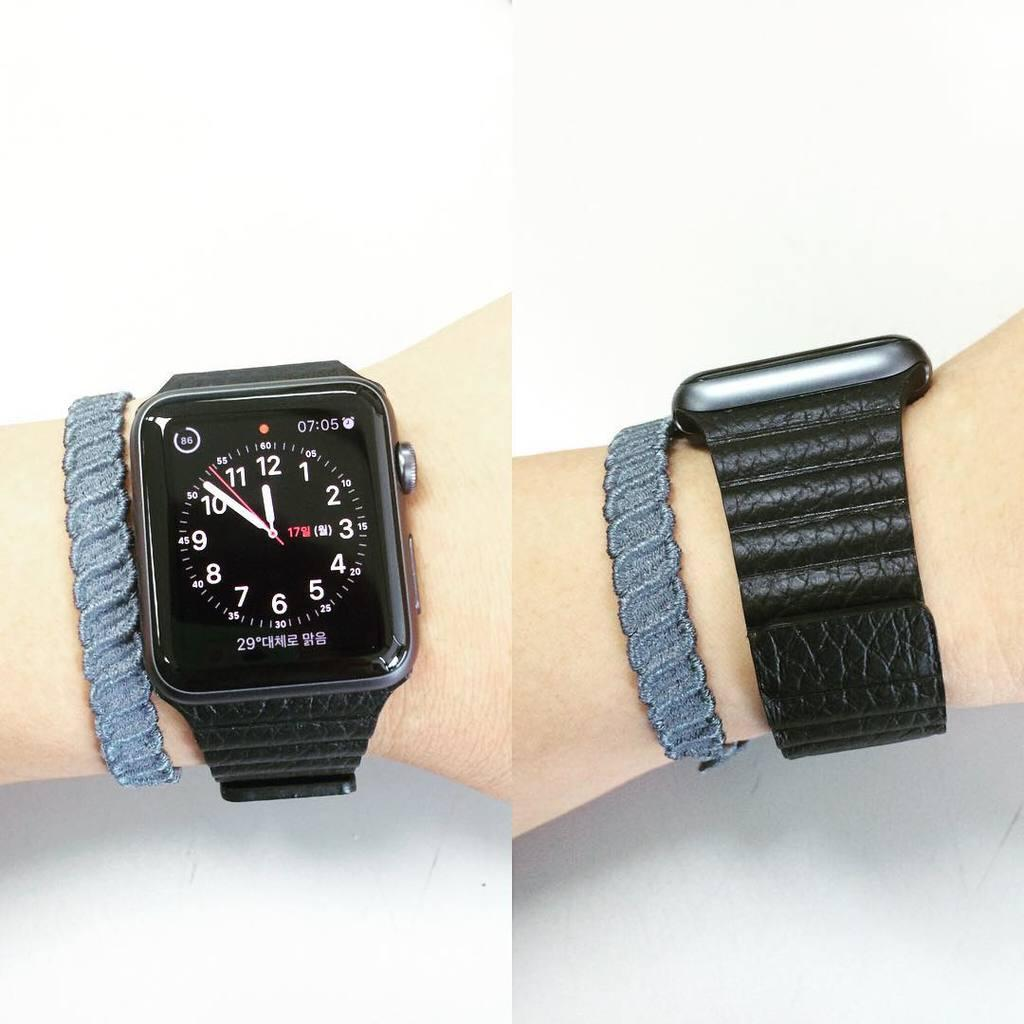What type of artwork is featured in the image? The image contains a collage. What is the main subject of the collage? The collage depicts a person's hand. What can be seen on the person's hand in the collage? The person's hand is wearing a black color watch. What type of bird is sitting on the mother's shoulder in the image? There is no mother or bird present in the image; it features a collage of a person's hand wearing a black color watch. 